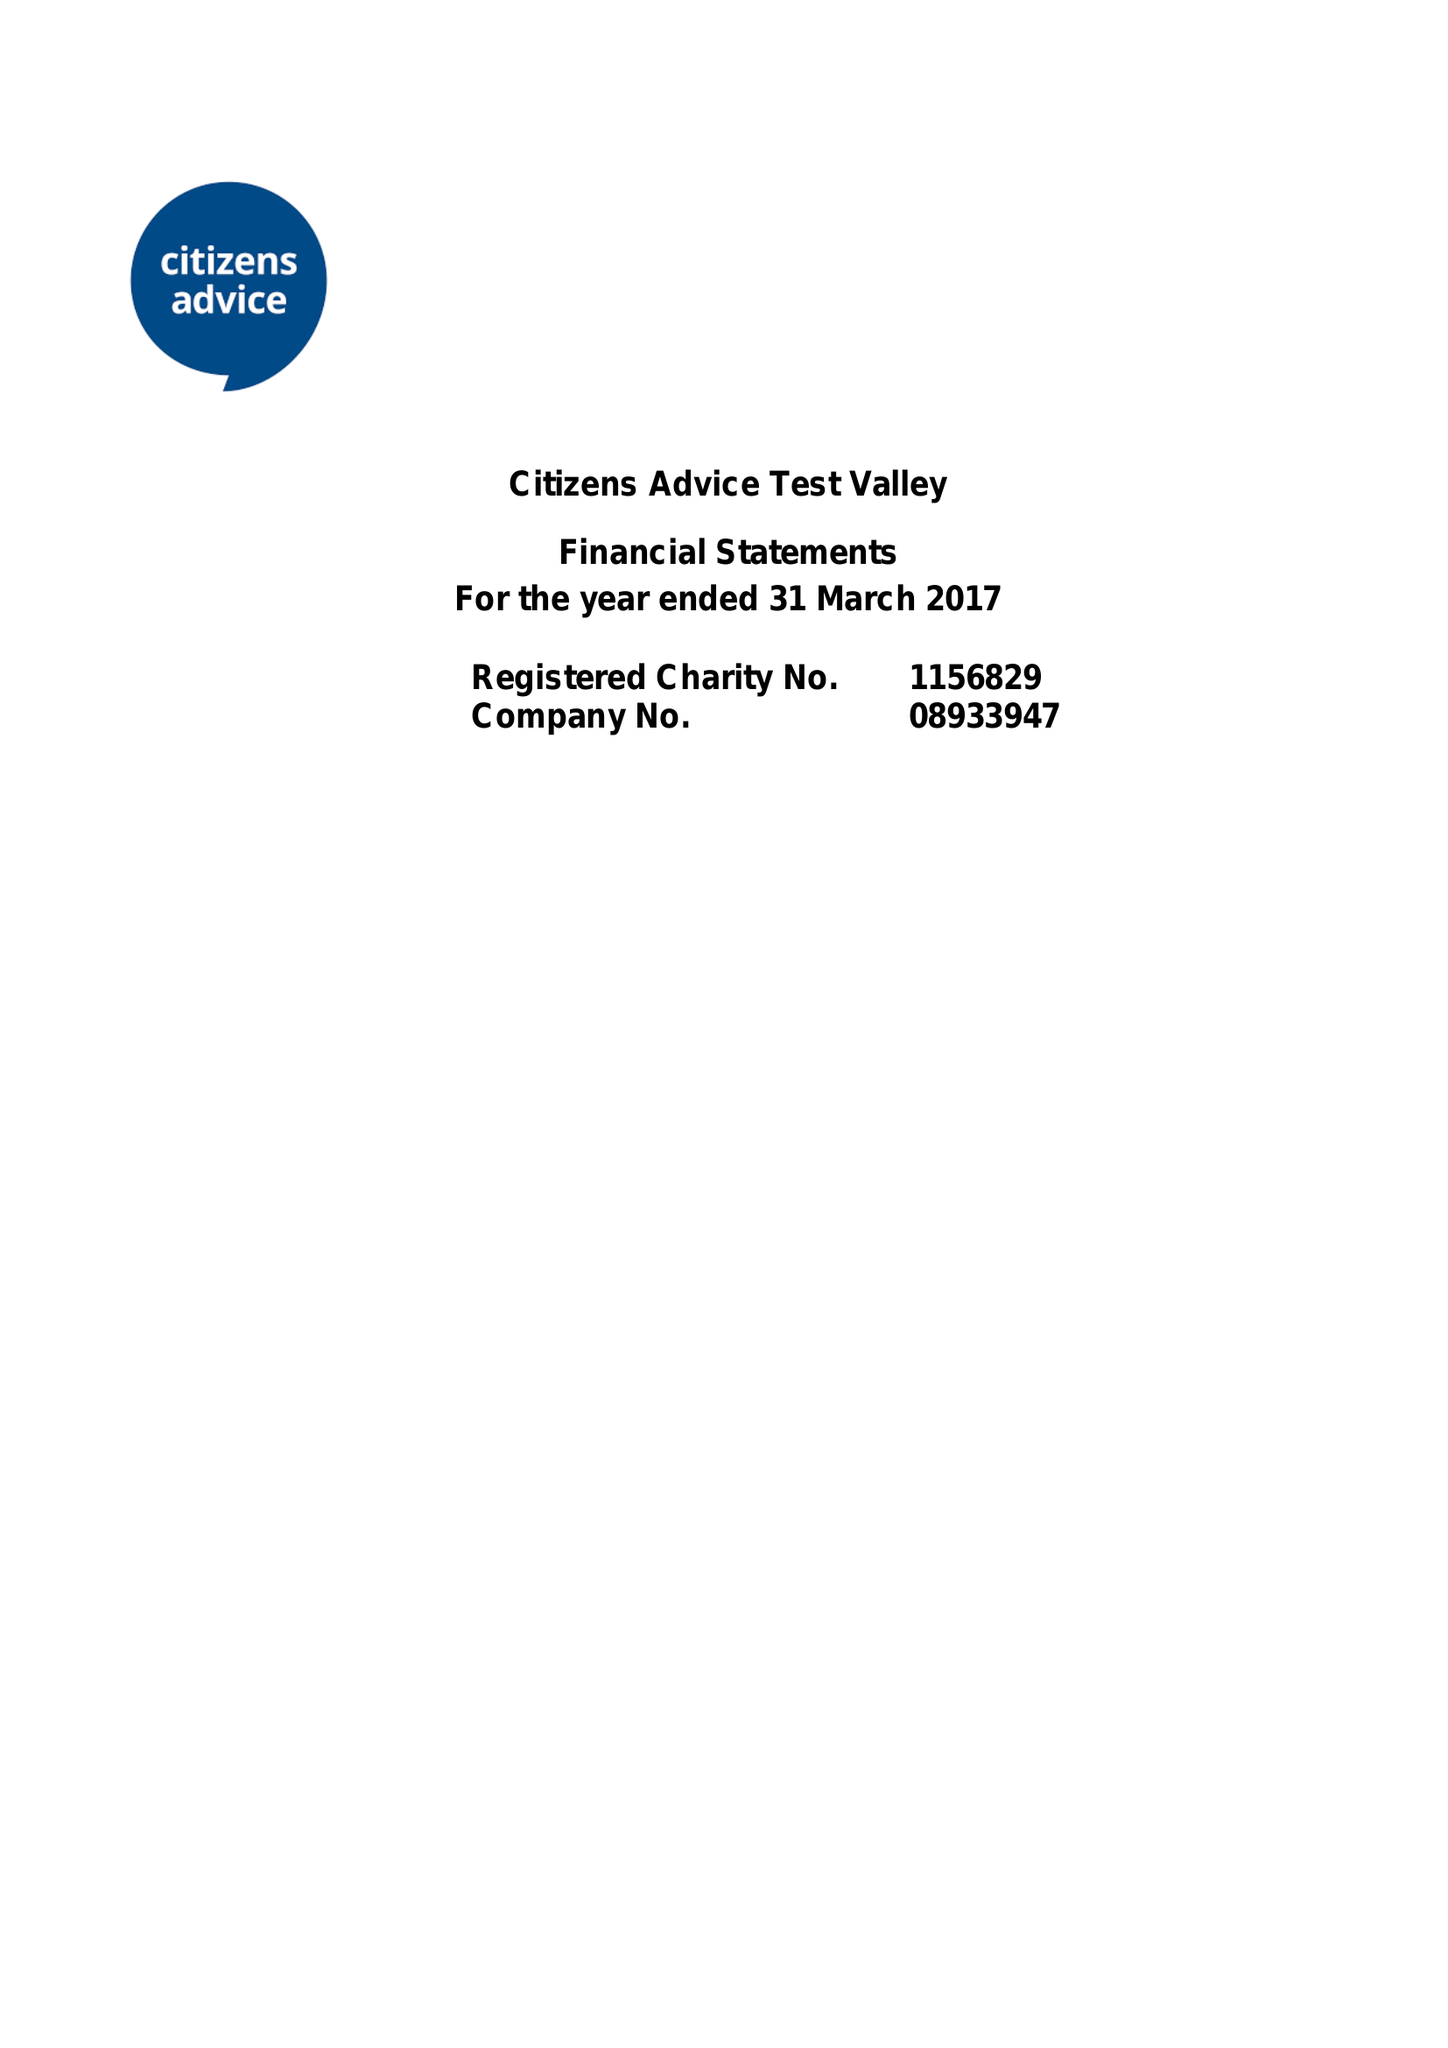What is the value for the spending_annually_in_british_pounds?
Answer the question using a single word or phrase. 283772.00 